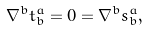Convert formula to latex. <formula><loc_0><loc_0><loc_500><loc_500>\nabla ^ { b } t _ { b } ^ { a } = 0 = \nabla ^ { b } s _ { b } ^ { a } ,</formula> 